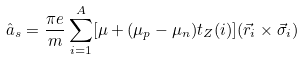Convert formula to latex. <formula><loc_0><loc_0><loc_500><loc_500>\hat { a } _ { s } = \frac { \pi e } { m } \sum _ { i = 1 } ^ { A } [ \mu + ( \mu _ { p } - \mu _ { n } ) t _ { Z } ( i ) ] ( \vec { r } _ { i } \times \vec { \sigma } _ { i } )</formula> 